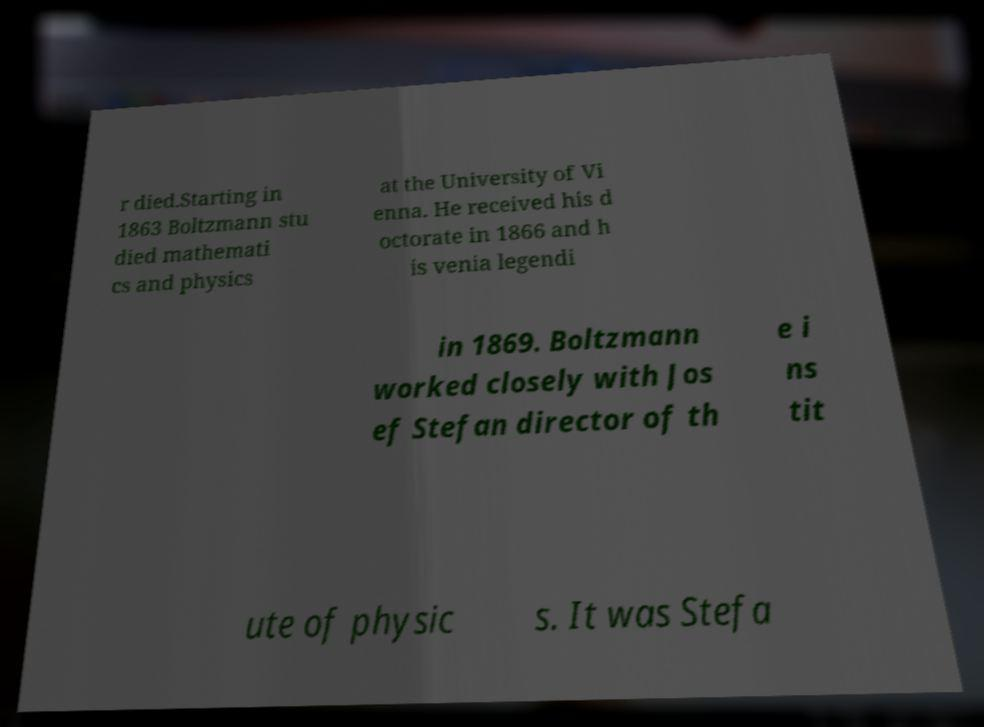There's text embedded in this image that I need extracted. Can you transcribe it verbatim? r died.Starting in 1863 Boltzmann stu died mathemati cs and physics at the University of Vi enna. He received his d octorate in 1866 and h is venia legendi in 1869. Boltzmann worked closely with Jos ef Stefan director of th e i ns tit ute of physic s. It was Stefa 